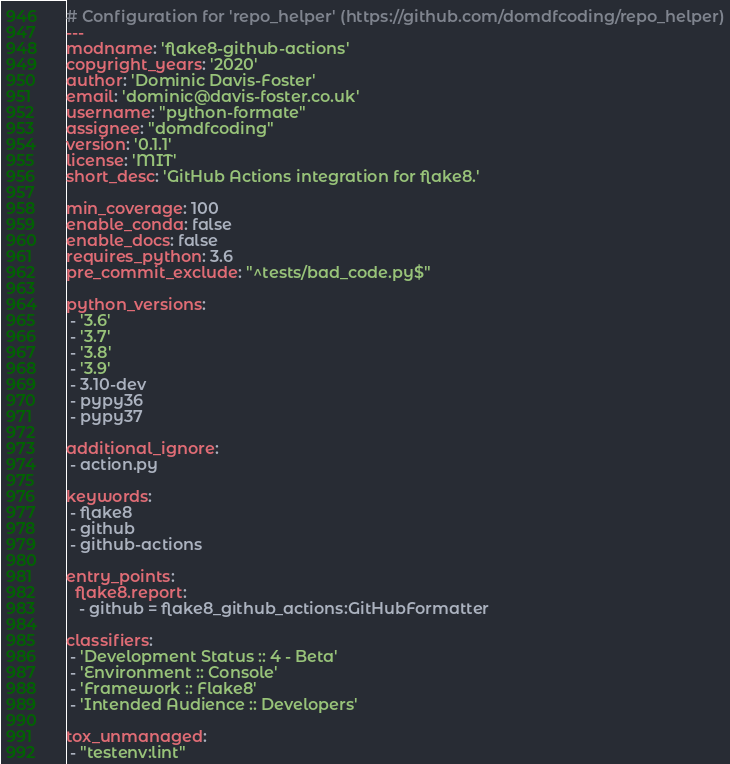Convert code to text. <code><loc_0><loc_0><loc_500><loc_500><_YAML_># Configuration for 'repo_helper' (https://github.com/domdfcoding/repo_helper)
---
modname: 'flake8-github-actions'
copyright_years: '2020'
author: 'Dominic Davis-Foster'
email: 'dominic@davis-foster.co.uk'
username: "python-formate"
assignee: "domdfcoding"
version: '0.1.1'
license: 'MIT'
short_desc: 'GitHub Actions integration for flake8.'

min_coverage: 100
enable_conda: false
enable_docs: false
requires_python: 3.6
pre_commit_exclude: "^tests/bad_code.py$"

python_versions:
 - '3.6'
 - '3.7'
 - '3.8'
 - '3.9'
 - 3.10-dev
 - pypy36
 - pypy37

additional_ignore:
 - action.py

keywords:
 - flake8
 - github
 - github-actions

entry_points:
  flake8.report:
   - github = flake8_github_actions:GitHubFormatter

classifiers:
 - 'Development Status :: 4 - Beta'
 - 'Environment :: Console'
 - 'Framework :: Flake8'
 - 'Intended Audience :: Developers'

tox_unmanaged:
 - "testenv:lint"
</code> 